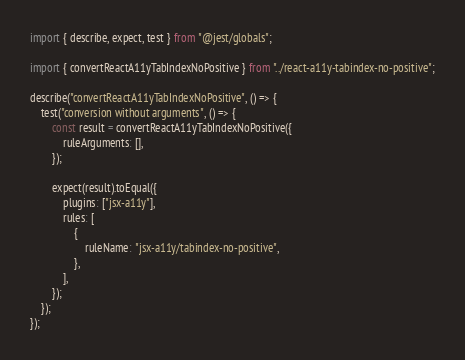<code> <loc_0><loc_0><loc_500><loc_500><_TypeScript_>import { describe, expect, test } from "@jest/globals";

import { convertReactA11yTabIndexNoPositive } from "../react-a11y-tabindex-no-positive";

describe("convertReactA11yTabIndexNoPositive", () => {
    test("conversion without arguments", () => {
        const result = convertReactA11yTabIndexNoPositive({
            ruleArguments: [],
        });

        expect(result).toEqual({
            plugins: ["jsx-a11y"],
            rules: [
                {
                    ruleName: "jsx-a11y/tabindex-no-positive",
                },
            ],
        });
    });
});
</code> 